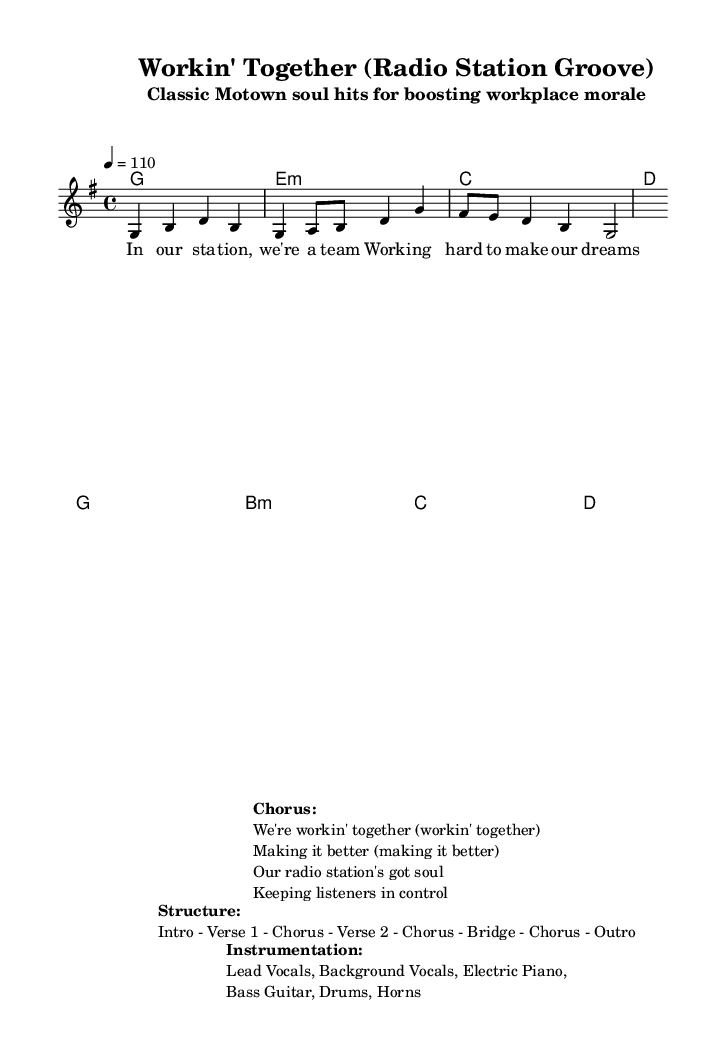What is the key signature of this music? The key signature is G major, which has one sharp (F#). This is determined from the `\key g \major` command in the `global` section.
Answer: G major What is the time signature of this piece? The time signature is 4/4, which means there are four beats in each measure and a quarter note receives one beat. This is indicated by the `\time 4/4` command in the `global` section.
Answer: 4/4 What is the tempo marking? The tempo marking is 110 beats per minute, as indicated by the `\tempo 4 = 110` command within the `global` section.
Answer: 110 What is the structure of the song? The structure includes an Intro, Verse 1, Chorus, Verse 2, Chorus, Bridge, and Outro. This information is laid out in the `\markup` section under "Structure."
Answer: Intro - Verse 1 - Chorus - Verse 2 - Chorus - Bridge - Chorus - Outro Which instruments are featured in this piece? The instruments listed are Lead Vocals, Background Vocals, Electric Piano, Bass Guitar, Drums, and Horns. This is detailed in the `\markup` section under "Instrumentation."
Answer: Lead Vocals, Background Vocals, Electric Piano, Bass Guitar, Drums, Horns What is the main theme of the lyrics in the verses? The main theme focuses on teamwork and striving to achieve shared dreams in a radio station context, as expressed in the lyrics provided for the verse.
Answer: Teamwork and dreams How many measures are there in the chords section? There are eight measures in the chord section. Each chord is processed in a separate line with its corresponding unity governing the length of the measure. This can be seen in the `\harmonies` section.
Answer: 8 